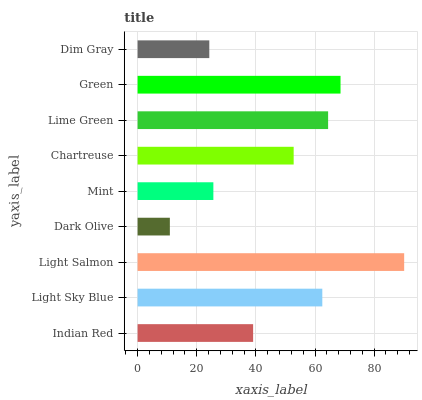Is Dark Olive the minimum?
Answer yes or no. Yes. Is Light Salmon the maximum?
Answer yes or no. Yes. Is Light Sky Blue the minimum?
Answer yes or no. No. Is Light Sky Blue the maximum?
Answer yes or no. No. Is Light Sky Blue greater than Indian Red?
Answer yes or no. Yes. Is Indian Red less than Light Sky Blue?
Answer yes or no. Yes. Is Indian Red greater than Light Sky Blue?
Answer yes or no. No. Is Light Sky Blue less than Indian Red?
Answer yes or no. No. Is Chartreuse the high median?
Answer yes or no. Yes. Is Chartreuse the low median?
Answer yes or no. Yes. Is Indian Red the high median?
Answer yes or no. No. Is Indian Red the low median?
Answer yes or no. No. 